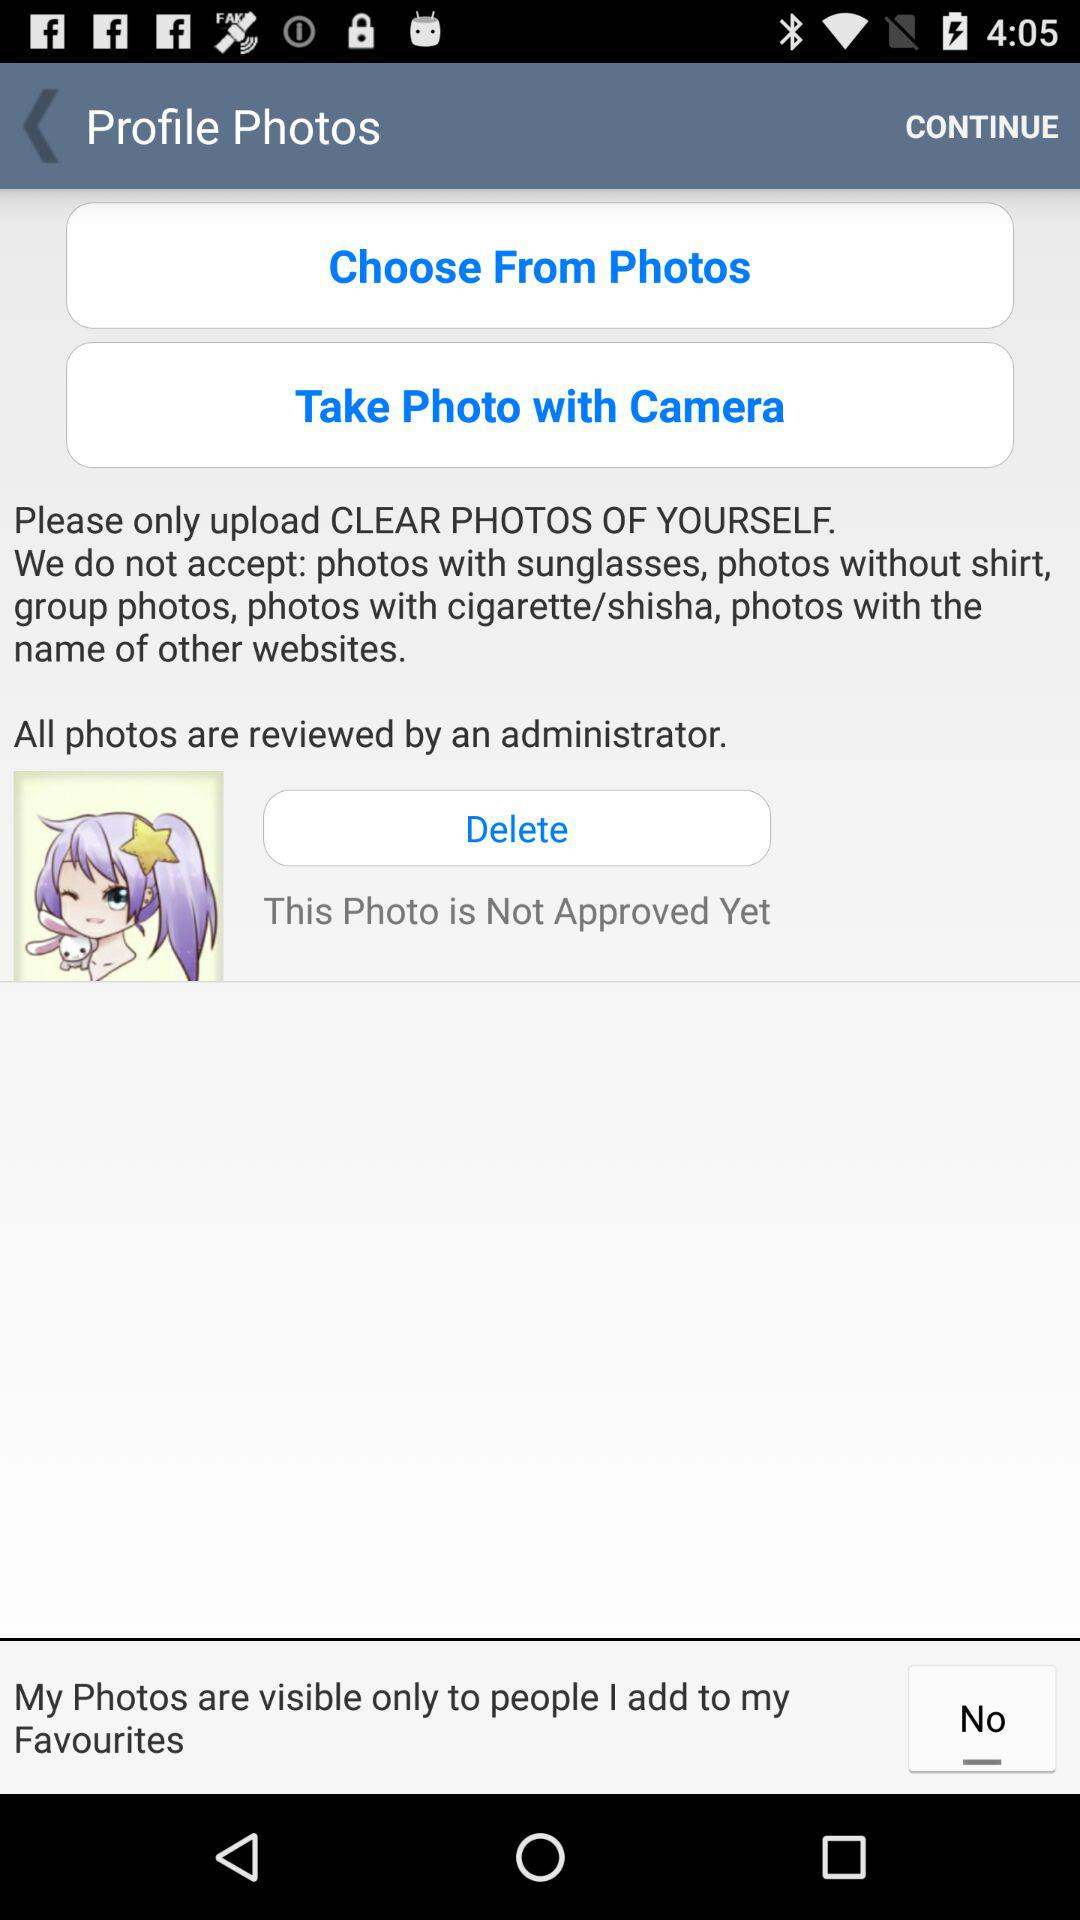Who has reviewed all the photos? The photos are reviewed by an administrator. 